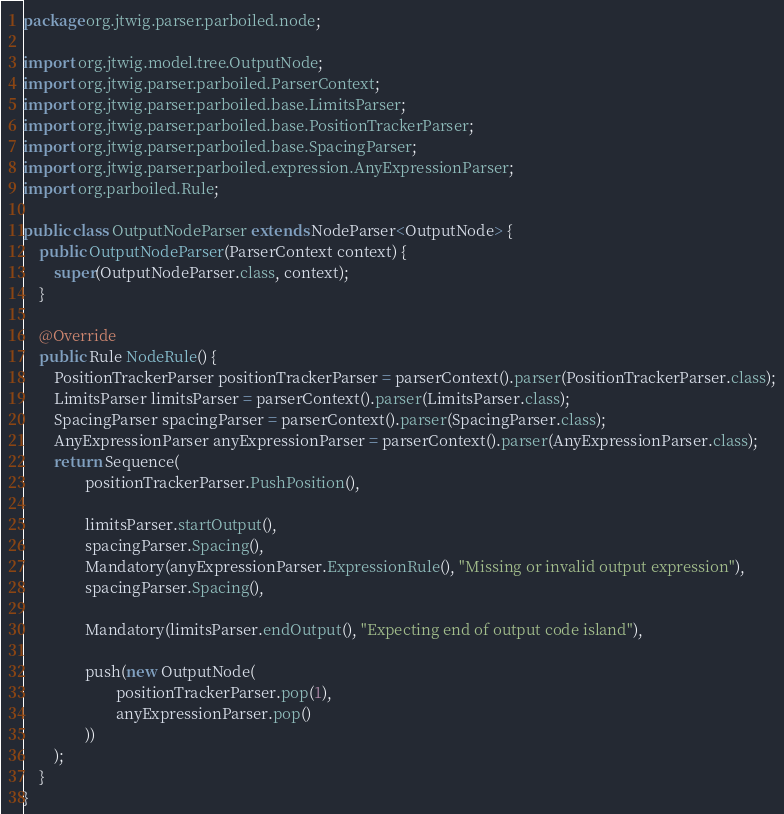<code> <loc_0><loc_0><loc_500><loc_500><_Java_>package org.jtwig.parser.parboiled.node;

import org.jtwig.model.tree.OutputNode;
import org.jtwig.parser.parboiled.ParserContext;
import org.jtwig.parser.parboiled.base.LimitsParser;
import org.jtwig.parser.parboiled.base.PositionTrackerParser;
import org.jtwig.parser.parboiled.base.SpacingParser;
import org.jtwig.parser.parboiled.expression.AnyExpressionParser;
import org.parboiled.Rule;

public class OutputNodeParser extends NodeParser<OutputNode> {
    public OutputNodeParser(ParserContext context) {
        super(OutputNodeParser.class, context);
    }

    @Override
    public Rule NodeRule() {
        PositionTrackerParser positionTrackerParser = parserContext().parser(PositionTrackerParser.class);
        LimitsParser limitsParser = parserContext().parser(LimitsParser.class);
        SpacingParser spacingParser = parserContext().parser(SpacingParser.class);
        AnyExpressionParser anyExpressionParser = parserContext().parser(AnyExpressionParser.class);
        return Sequence(
                positionTrackerParser.PushPosition(),

                limitsParser.startOutput(),
                spacingParser.Spacing(),
                Mandatory(anyExpressionParser.ExpressionRule(), "Missing or invalid output expression"),
                spacingParser.Spacing(),

                Mandatory(limitsParser.endOutput(), "Expecting end of output code island"),

                push(new OutputNode(
                        positionTrackerParser.pop(1),
                        anyExpressionParser.pop()
                ))
        );
    }
}
</code> 